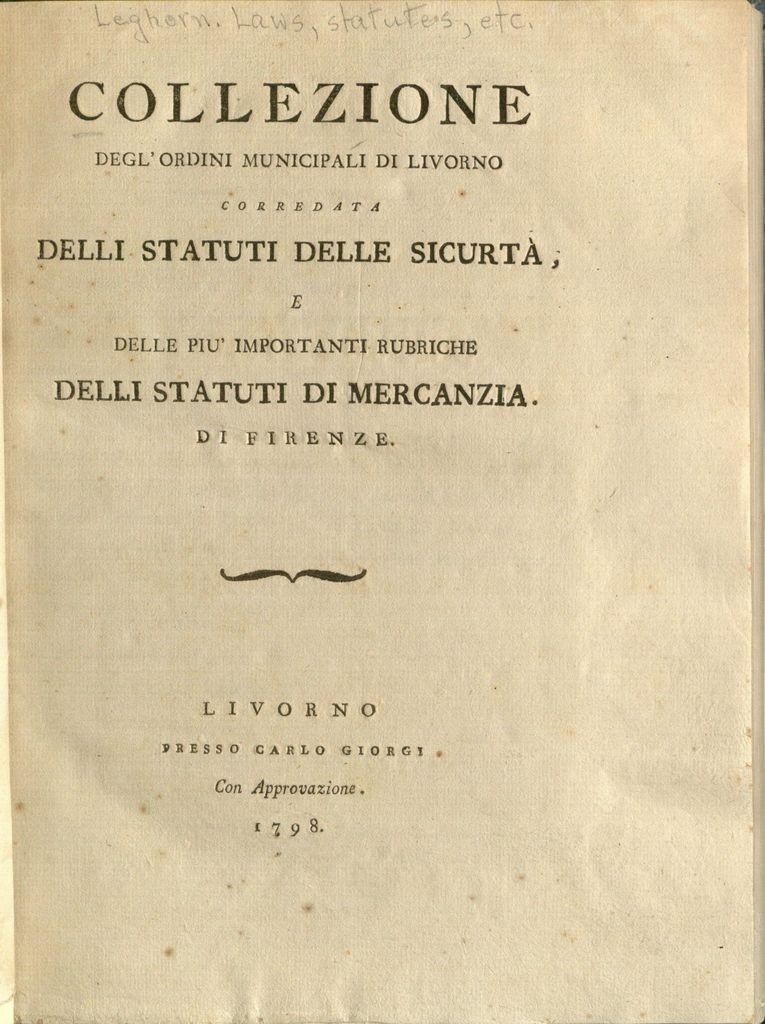<image>
Summarize the visual content of the image. Pencilled in on the cover of "Collezione Degl'ordini municipali de livorno" are the words 'Leghorn Laws, statutes, etc.' 